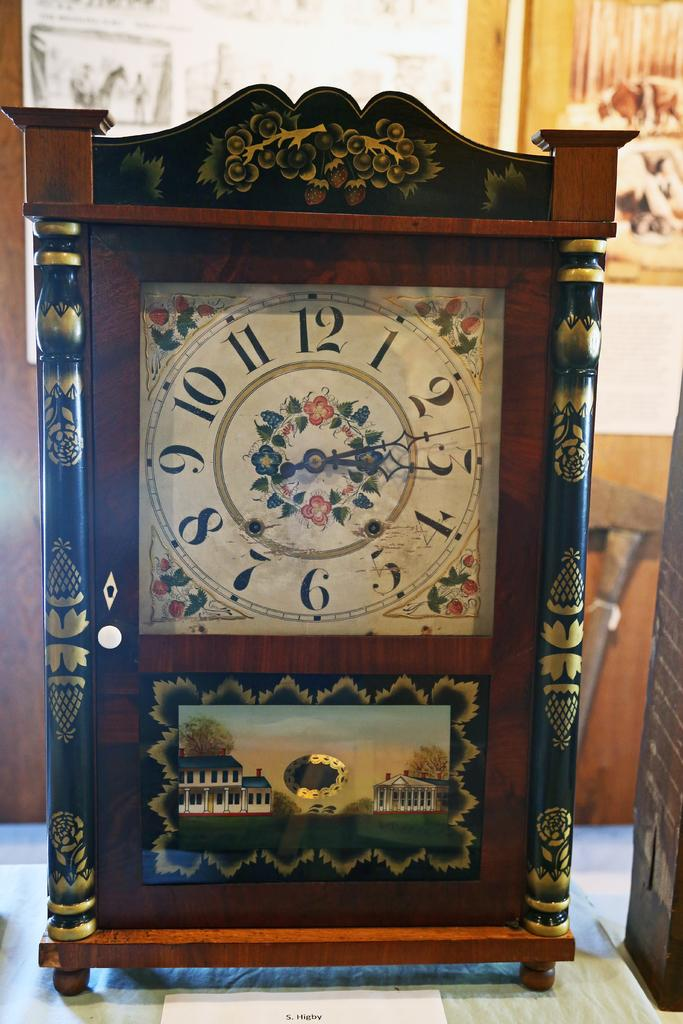<image>
Relay a brief, clear account of the picture shown. A painted clock has the number 12 at the top of the clock face. 